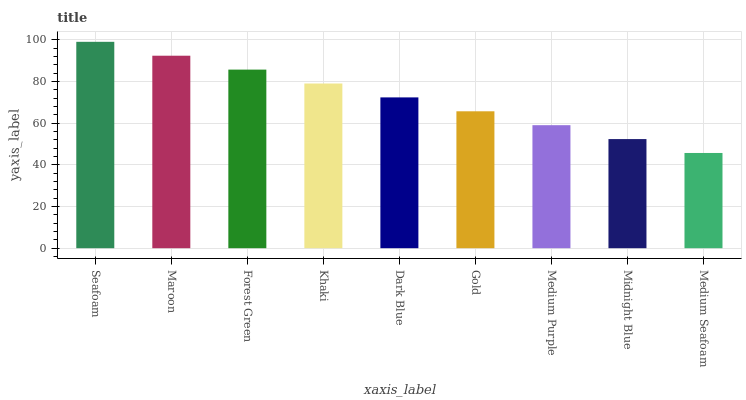Is Medium Seafoam the minimum?
Answer yes or no. Yes. Is Seafoam the maximum?
Answer yes or no. Yes. Is Maroon the minimum?
Answer yes or no. No. Is Maroon the maximum?
Answer yes or no. No. Is Seafoam greater than Maroon?
Answer yes or no. Yes. Is Maroon less than Seafoam?
Answer yes or no. Yes. Is Maroon greater than Seafoam?
Answer yes or no. No. Is Seafoam less than Maroon?
Answer yes or no. No. Is Dark Blue the high median?
Answer yes or no. Yes. Is Dark Blue the low median?
Answer yes or no. Yes. Is Maroon the high median?
Answer yes or no. No. Is Maroon the low median?
Answer yes or no. No. 